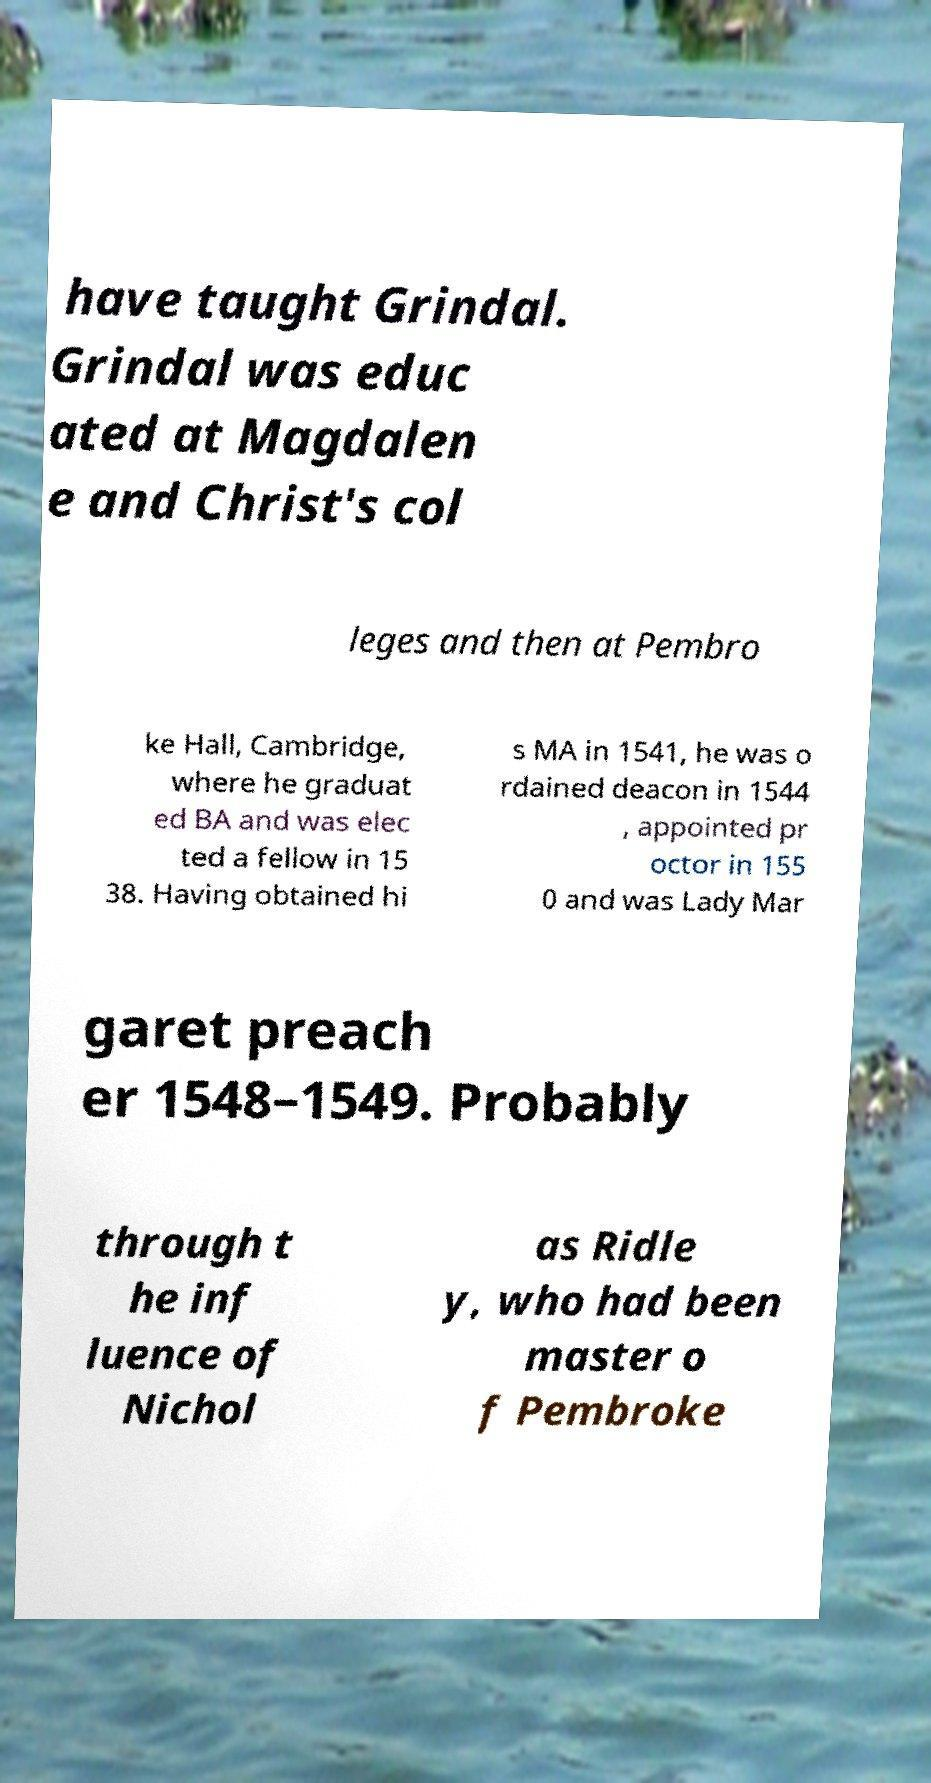There's text embedded in this image that I need extracted. Can you transcribe it verbatim? have taught Grindal. Grindal was educ ated at Magdalen e and Christ's col leges and then at Pembro ke Hall, Cambridge, where he graduat ed BA and was elec ted a fellow in 15 38. Having obtained hi s MA in 1541, he was o rdained deacon in 1544 , appointed pr octor in 155 0 and was Lady Mar garet preach er 1548–1549. Probably through t he inf luence of Nichol as Ridle y, who had been master o f Pembroke 